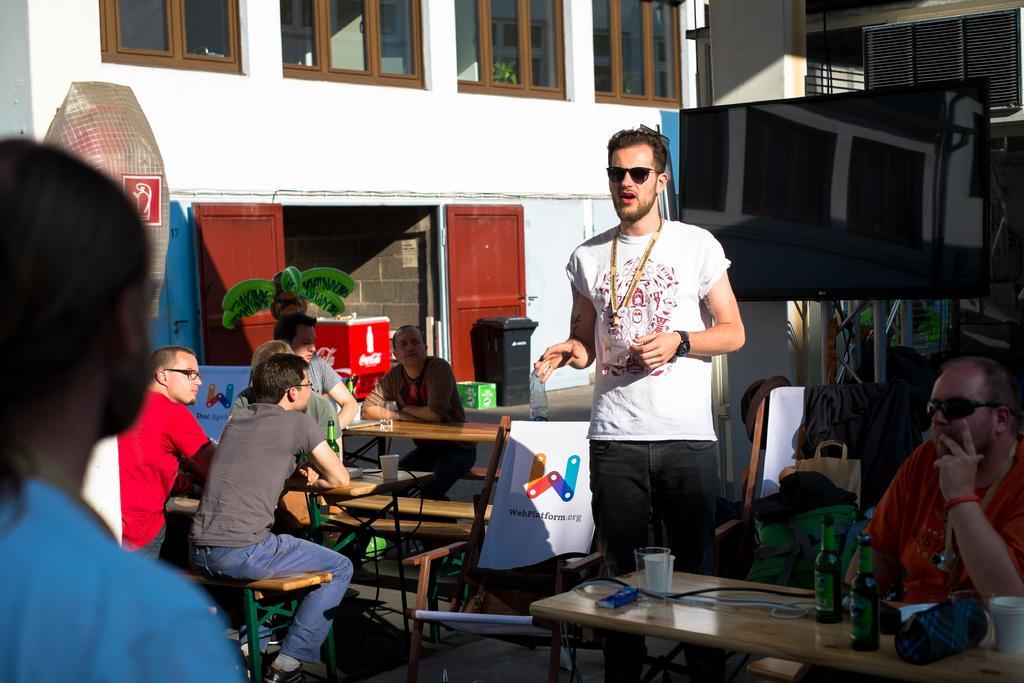Describe this image in one or two sentences. There is a person wearing goggles, tag and watch is standing and talking. There are many tables and benches. On the benches some people are sitting. On the table there are many items like glasses, bottles, cups, pouch. Also there are chairs with banners on that. In the back there is a building with windows, doors. Also there is a screen with a stand. 